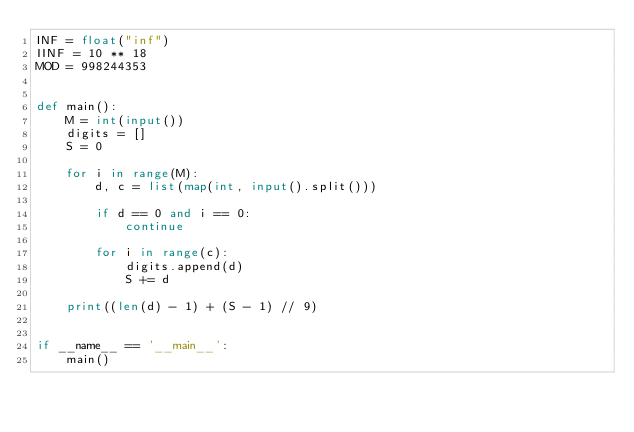Convert code to text. <code><loc_0><loc_0><loc_500><loc_500><_Python_>INF = float("inf")
IINF = 10 ** 18
MOD = 998244353


def main():
    M = int(input())
    digits = []
    S = 0

    for i in range(M):
        d, c = list(map(int, input().split()))

        if d == 0 and i == 0:
            continue

        for i in range(c):
            digits.append(d)
            S += d

    print((len(d) - 1) + (S - 1) // 9)


if __name__ == '__main__':
    main()
</code> 